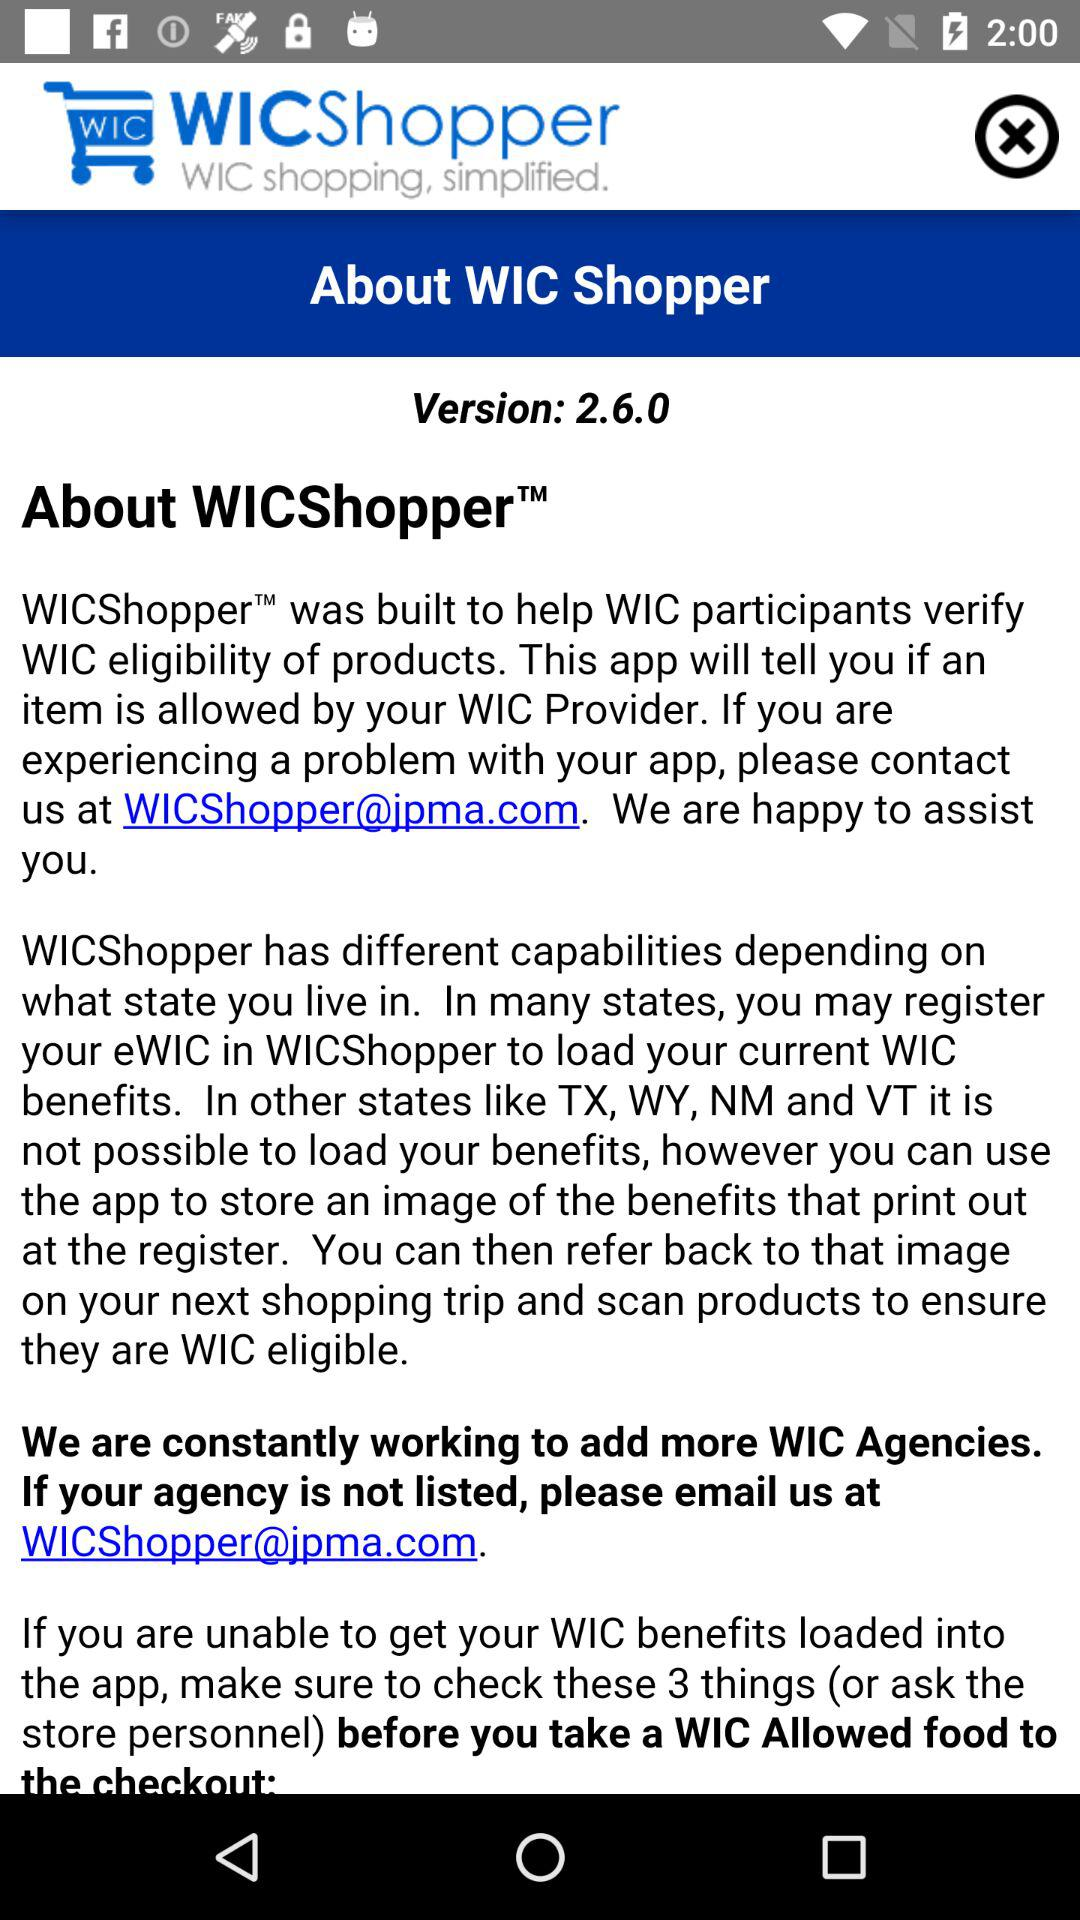What is the version? The version is 2.6.0. 